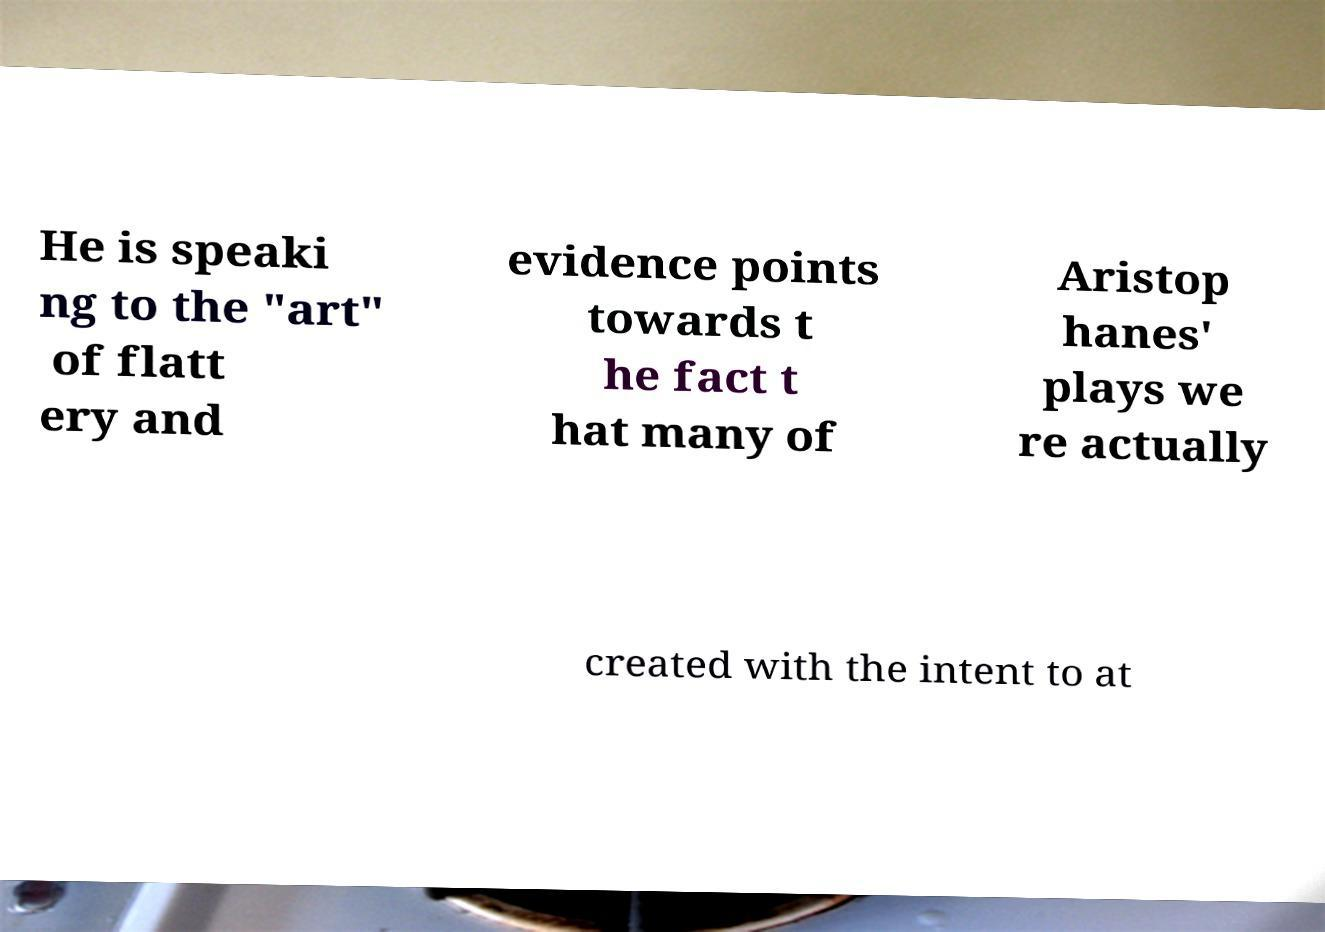I need the written content from this picture converted into text. Can you do that? He is speaki ng to the "art" of flatt ery and evidence points towards t he fact t hat many of Aristop hanes' plays we re actually created with the intent to at 